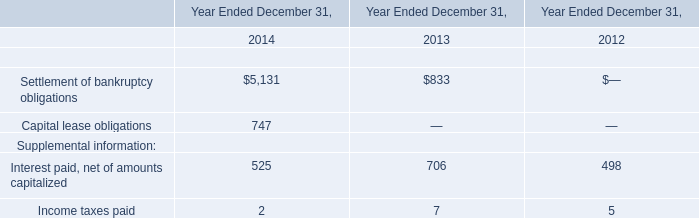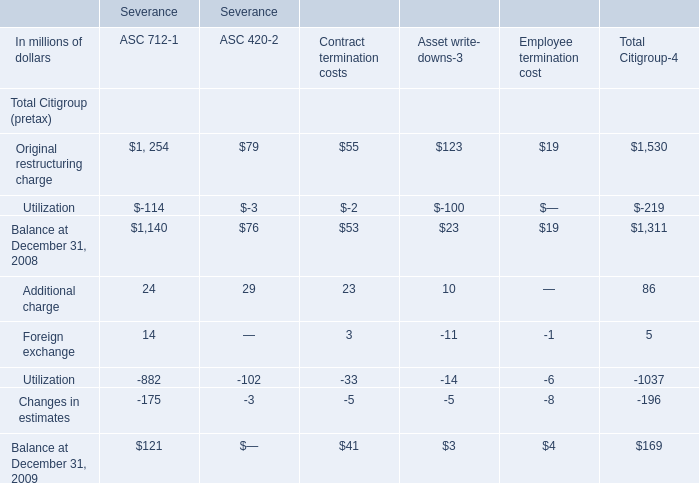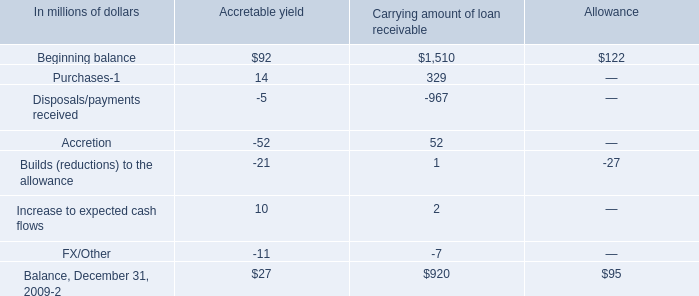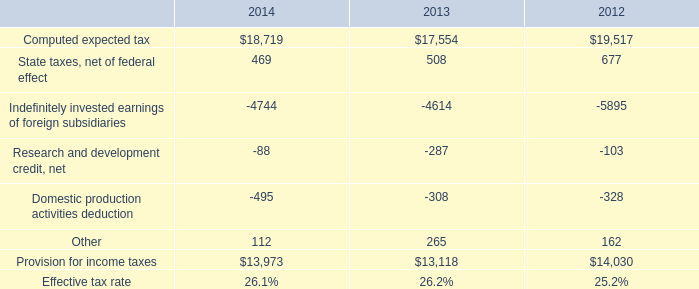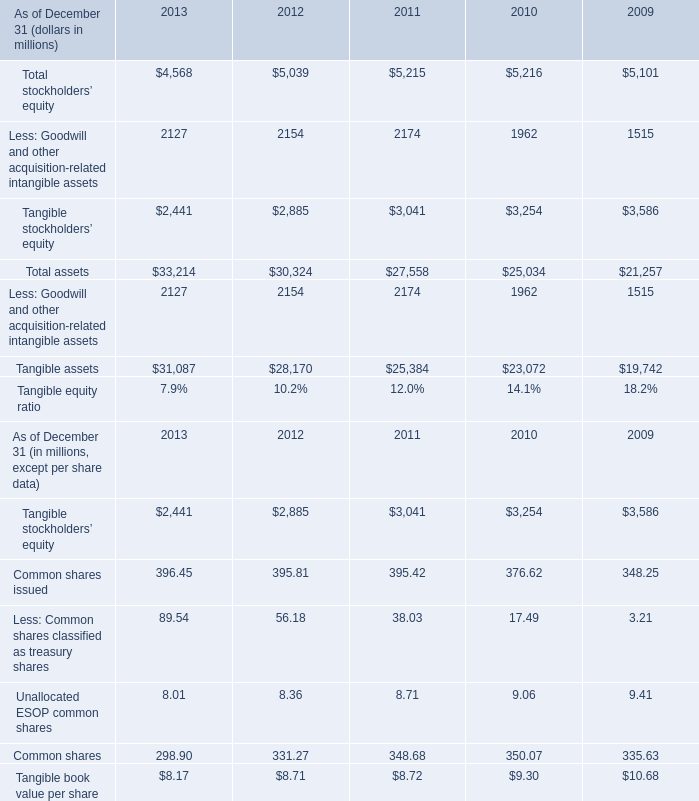In the year/section with the most Balance, what is the growth rate of Balance? 
Computations: (169 / 1311)
Answer: 0.12891. 